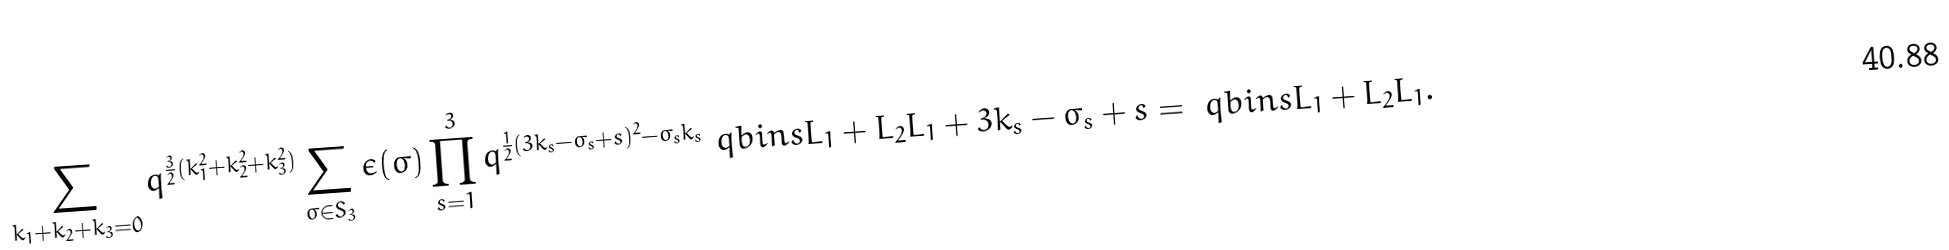Convert formula to latex. <formula><loc_0><loc_0><loc_500><loc_500>\sum _ { k _ { 1 } + k _ { 2 } + k _ { 3 } = 0 } q ^ { \frac { 3 } { 2 } ( k _ { 1 } ^ { 2 } + k _ { 2 } ^ { 2 } + k _ { 3 } ^ { 2 } ) } \sum _ { \sigma \in S _ { 3 } } \epsilon ( \sigma ) \prod _ { s = 1 } ^ { 3 } q ^ { \frac { 1 } { 2 } ( 3 k _ { s } - \sigma _ { s } + s ) ^ { 2 } - \sigma _ { s } k _ { s } } \ q b i n s { L _ { 1 } + L _ { 2 } } { L _ { 1 } + 3 k _ { s } - \sigma _ { s } + s } = \ q b i n s { L _ { 1 } + L _ { 2 } } { L _ { 1 } } .</formula> 